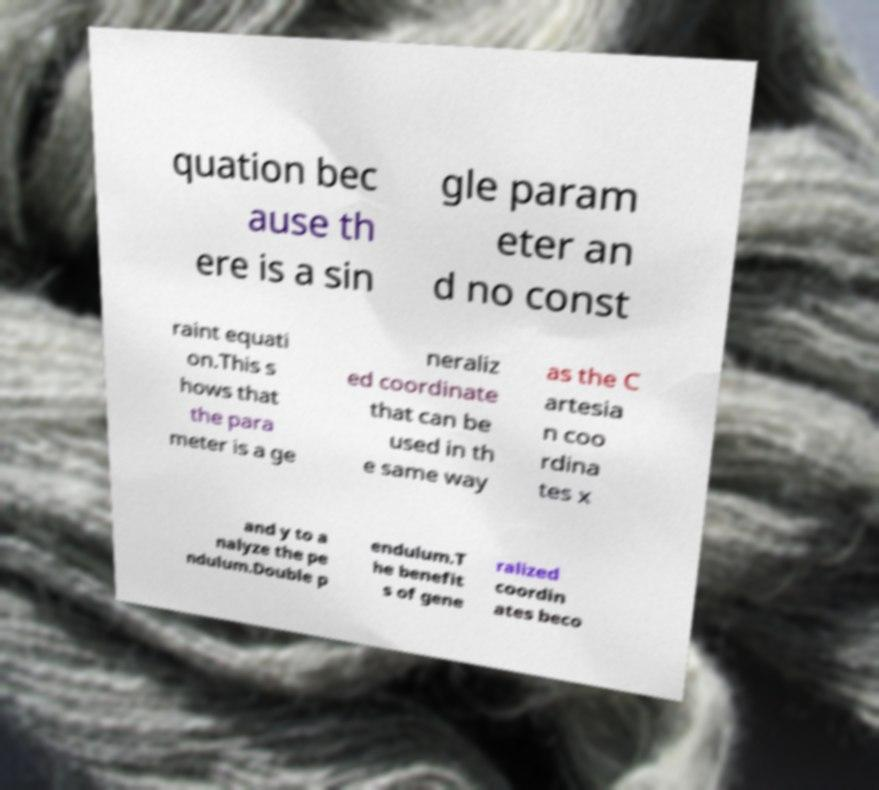There's text embedded in this image that I need extracted. Can you transcribe it verbatim? quation bec ause th ere is a sin gle param eter an d no const raint equati on.This s hows that the para meter is a ge neraliz ed coordinate that can be used in th e same way as the C artesia n coo rdina tes x and y to a nalyze the pe ndulum.Double p endulum.T he benefit s of gene ralized coordin ates beco 